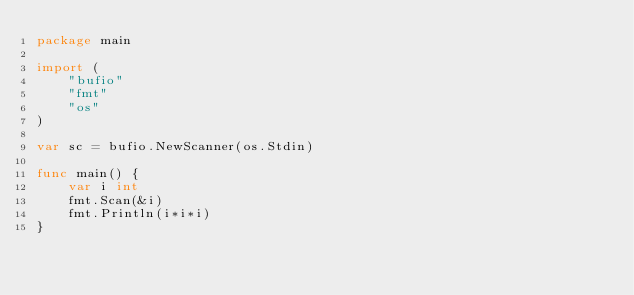Convert code to text. <code><loc_0><loc_0><loc_500><loc_500><_Go_>package main

import (
	"bufio"
	"fmt"
	"os"
)

var sc = bufio.NewScanner(os.Stdin)

func main() {
	var i int
	fmt.Scan(&i)
	fmt.Println(i*i*i)
}

</code> 